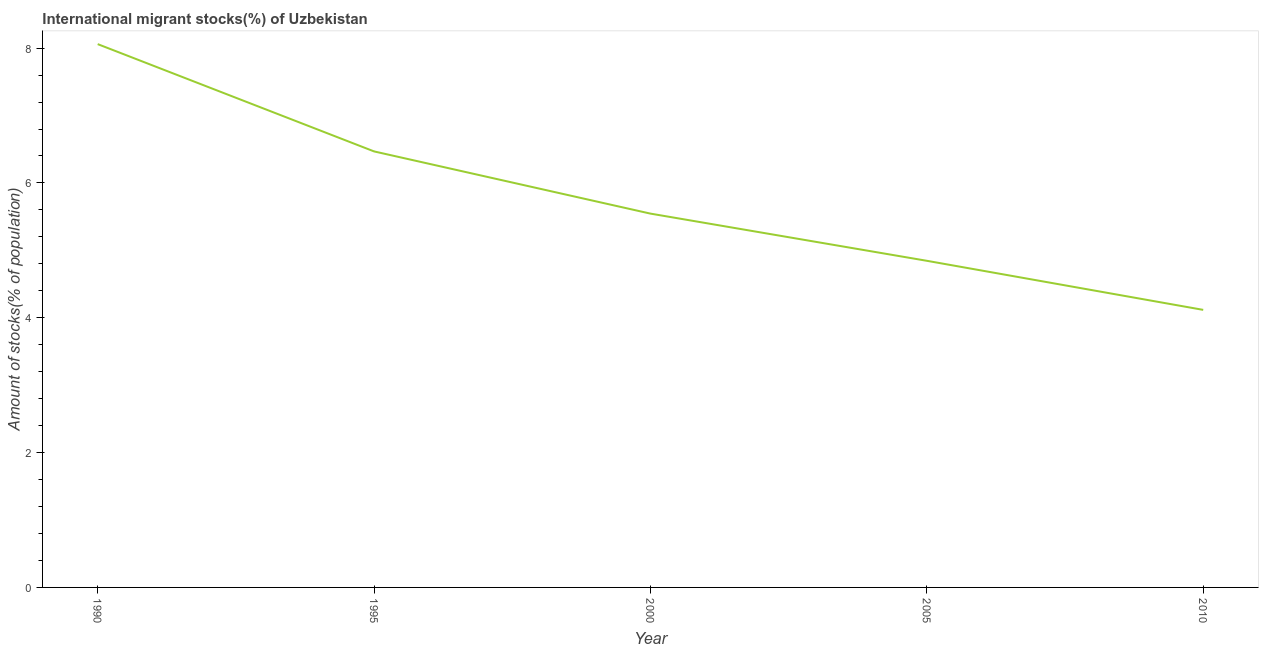What is the number of international migrant stocks in 1990?
Provide a succinct answer. 8.06. Across all years, what is the maximum number of international migrant stocks?
Offer a terse response. 8.06. Across all years, what is the minimum number of international migrant stocks?
Provide a short and direct response. 4.12. In which year was the number of international migrant stocks maximum?
Provide a succinct answer. 1990. In which year was the number of international migrant stocks minimum?
Keep it short and to the point. 2010. What is the sum of the number of international migrant stocks?
Your answer should be compact. 29.03. What is the difference between the number of international migrant stocks in 2000 and 2005?
Provide a short and direct response. 0.7. What is the average number of international migrant stocks per year?
Your answer should be very brief. 5.81. What is the median number of international migrant stocks?
Give a very brief answer. 5.55. What is the ratio of the number of international migrant stocks in 2005 to that in 2010?
Ensure brevity in your answer.  1.18. Is the number of international migrant stocks in 2000 less than that in 2010?
Your answer should be very brief. No. What is the difference between the highest and the second highest number of international migrant stocks?
Ensure brevity in your answer.  1.59. Is the sum of the number of international migrant stocks in 1990 and 2010 greater than the maximum number of international migrant stocks across all years?
Give a very brief answer. Yes. What is the difference between the highest and the lowest number of international migrant stocks?
Your response must be concise. 3.94. In how many years, is the number of international migrant stocks greater than the average number of international migrant stocks taken over all years?
Offer a terse response. 2. Does the number of international migrant stocks monotonically increase over the years?
Provide a succinct answer. No. How many lines are there?
Make the answer very short. 1. How many years are there in the graph?
Offer a terse response. 5. Are the values on the major ticks of Y-axis written in scientific E-notation?
Offer a terse response. No. Does the graph contain grids?
Give a very brief answer. No. What is the title of the graph?
Your answer should be very brief. International migrant stocks(%) of Uzbekistan. What is the label or title of the Y-axis?
Your answer should be very brief. Amount of stocks(% of population). What is the Amount of stocks(% of population) of 1990?
Provide a short and direct response. 8.06. What is the Amount of stocks(% of population) in 1995?
Your response must be concise. 6.47. What is the Amount of stocks(% of population) in 2000?
Your answer should be compact. 5.55. What is the Amount of stocks(% of population) in 2005?
Ensure brevity in your answer.  4.85. What is the Amount of stocks(% of population) of 2010?
Ensure brevity in your answer.  4.12. What is the difference between the Amount of stocks(% of population) in 1990 and 1995?
Your answer should be very brief. 1.59. What is the difference between the Amount of stocks(% of population) in 1990 and 2000?
Ensure brevity in your answer.  2.51. What is the difference between the Amount of stocks(% of population) in 1990 and 2005?
Provide a short and direct response. 3.21. What is the difference between the Amount of stocks(% of population) in 1990 and 2010?
Ensure brevity in your answer.  3.94. What is the difference between the Amount of stocks(% of population) in 1995 and 2000?
Provide a succinct answer. 0.92. What is the difference between the Amount of stocks(% of population) in 1995 and 2005?
Offer a terse response. 1.62. What is the difference between the Amount of stocks(% of population) in 1995 and 2010?
Offer a terse response. 2.35. What is the difference between the Amount of stocks(% of population) in 2000 and 2005?
Offer a terse response. 0.7. What is the difference between the Amount of stocks(% of population) in 2000 and 2010?
Make the answer very short. 1.43. What is the difference between the Amount of stocks(% of population) in 2005 and 2010?
Your answer should be very brief. 0.73. What is the ratio of the Amount of stocks(% of population) in 1990 to that in 1995?
Your answer should be very brief. 1.25. What is the ratio of the Amount of stocks(% of population) in 1990 to that in 2000?
Your answer should be very brief. 1.45. What is the ratio of the Amount of stocks(% of population) in 1990 to that in 2005?
Your response must be concise. 1.66. What is the ratio of the Amount of stocks(% of population) in 1990 to that in 2010?
Provide a succinct answer. 1.96. What is the ratio of the Amount of stocks(% of population) in 1995 to that in 2000?
Your answer should be compact. 1.17. What is the ratio of the Amount of stocks(% of population) in 1995 to that in 2005?
Your answer should be very brief. 1.33. What is the ratio of the Amount of stocks(% of population) in 1995 to that in 2010?
Ensure brevity in your answer.  1.57. What is the ratio of the Amount of stocks(% of population) in 2000 to that in 2005?
Provide a succinct answer. 1.14. What is the ratio of the Amount of stocks(% of population) in 2000 to that in 2010?
Your answer should be very brief. 1.35. What is the ratio of the Amount of stocks(% of population) in 2005 to that in 2010?
Give a very brief answer. 1.18. 